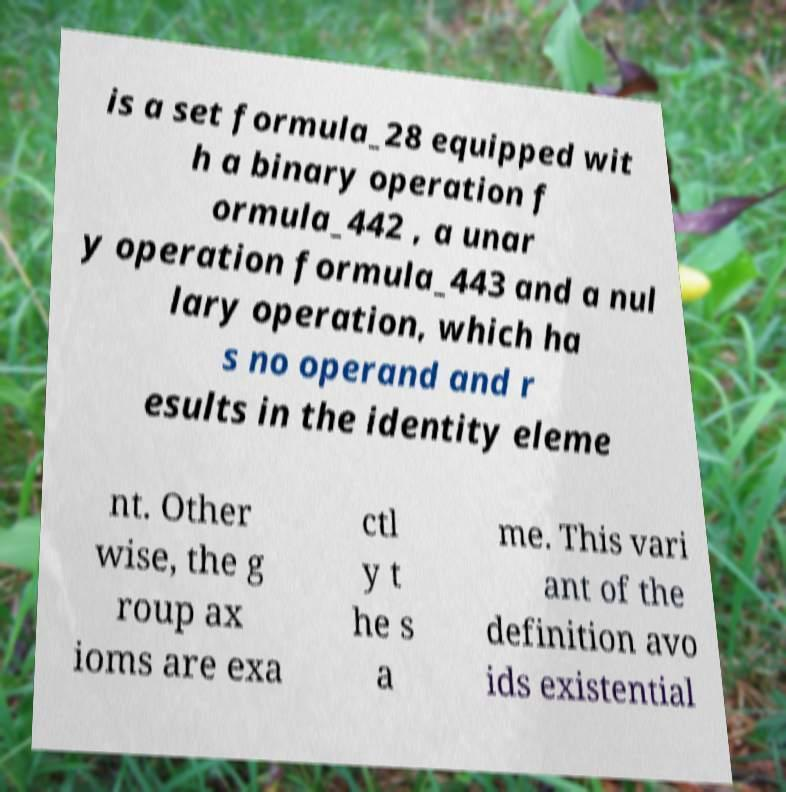Please identify and transcribe the text found in this image. is a set formula_28 equipped wit h a binary operation f ormula_442 , a unar y operation formula_443 and a nul lary operation, which ha s no operand and r esults in the identity eleme nt. Other wise, the g roup ax ioms are exa ctl y t he s a me. This vari ant of the definition avo ids existential 